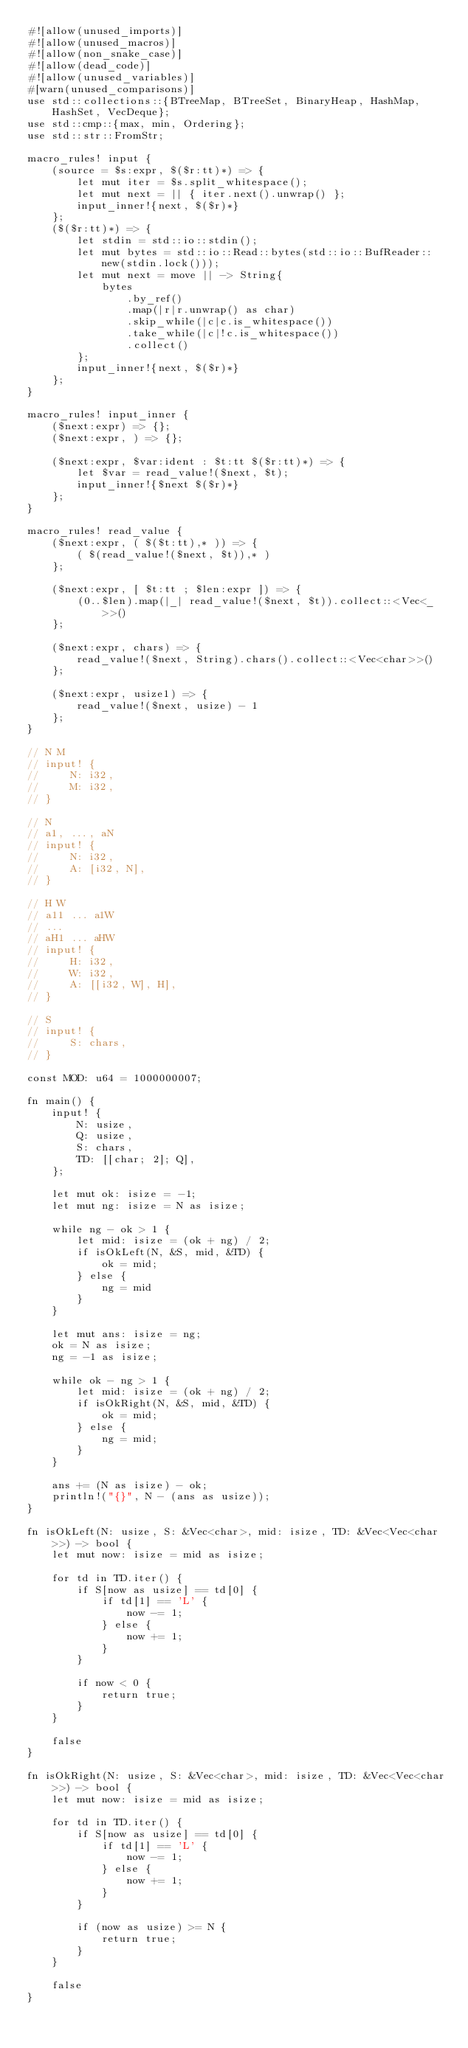Convert code to text. <code><loc_0><loc_0><loc_500><loc_500><_Rust_>#![allow(unused_imports)]
#![allow(unused_macros)]
#![allow(non_snake_case)]
#![allow(dead_code)]
#![allow(unused_variables)]
#[warn(unused_comparisons)]
use std::collections::{BTreeMap, BTreeSet, BinaryHeap, HashMap, HashSet, VecDeque};
use std::cmp::{max, min, Ordering};
use std::str::FromStr;

macro_rules! input {
    (source = $s:expr, $($r:tt)*) => {
        let mut iter = $s.split_whitespace();
        let mut next = || { iter.next().unwrap() };
        input_inner!{next, $($r)*}
    };
    ($($r:tt)*) => {
        let stdin = std::io::stdin();
        let mut bytes = std::io::Read::bytes(std::io::BufReader::new(stdin.lock()));
        let mut next = move || -> String{
            bytes
                .by_ref()
                .map(|r|r.unwrap() as char)
                .skip_while(|c|c.is_whitespace())
                .take_while(|c|!c.is_whitespace())
                .collect()
        };
        input_inner!{next, $($r)*}
    };
}

macro_rules! input_inner {
    ($next:expr) => {};
    ($next:expr, ) => {};

    ($next:expr, $var:ident : $t:tt $($r:tt)*) => {
        let $var = read_value!($next, $t);
        input_inner!{$next $($r)*}
    };
}

macro_rules! read_value {
    ($next:expr, ( $($t:tt),* )) => {
        ( $(read_value!($next, $t)),* )
    };

    ($next:expr, [ $t:tt ; $len:expr ]) => {
        (0..$len).map(|_| read_value!($next, $t)).collect::<Vec<_>>()
    };

    ($next:expr, chars) => {
        read_value!($next, String).chars().collect::<Vec<char>>()
    };

    ($next:expr, usize1) => {
        read_value!($next, usize) - 1
    };
}

// N M
// input! {
//     N: i32,
//     M: i32,
// }

// N
// a1, ..., aN
// input! {
//     N: i32,
//     A: [i32, N],
// }

// H W
// a11 ... a1W
// ...
// aH1 ... aHW
// input! {
//     H: i32,
//     W: i32,
//     A: [[i32, W], H],
// }

// S
// input! {
//     S: chars,
// }

const MOD: u64 = 1000000007;

fn main() {
    input! {
        N: usize,
        Q: usize,
        S: chars,
        TD: [[char; 2]; Q],
    };

    let mut ok: isize = -1;
    let mut ng: isize = N as isize;

    while ng - ok > 1 {
        let mid: isize = (ok + ng) / 2;
        if isOkLeft(N, &S, mid, &TD) {
            ok = mid;
        } else {
            ng = mid
        }
    }

    let mut ans: isize = ng;
    ok = N as isize;
    ng = -1 as isize;

    while ok - ng > 1 {
        let mid: isize = (ok + ng) / 2;
        if isOkRight(N, &S, mid, &TD) {
            ok = mid;
        } else {
            ng = mid;
        }
    }

    ans += (N as isize) - ok;
    println!("{}", N - (ans as usize));
}

fn isOkLeft(N: usize, S: &Vec<char>, mid: isize, TD: &Vec<Vec<char>>) -> bool {
    let mut now: isize = mid as isize;

    for td in TD.iter() {
        if S[now as usize] == td[0] {
            if td[1] == 'L' {
                now -= 1;
            } else {
                now += 1;
            }
        }

        if now < 0 {
            return true;
        }
    }

    false
}

fn isOkRight(N: usize, S: &Vec<char>, mid: isize, TD: &Vec<Vec<char>>) -> bool {
    let mut now: isize = mid as isize;

    for td in TD.iter() {
        if S[now as usize] == td[0] {
            if td[1] == 'L' {
                now -= 1;
            } else {
                now += 1;
            }
        }

        if (now as usize) >= N {
            return true;
        }
    }

    false
}</code> 